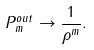Convert formula to latex. <formula><loc_0><loc_0><loc_500><loc_500>P ^ { o u t } _ { m } \rightarrow \frac { 1 } { \rho ^ { m } } .</formula> 